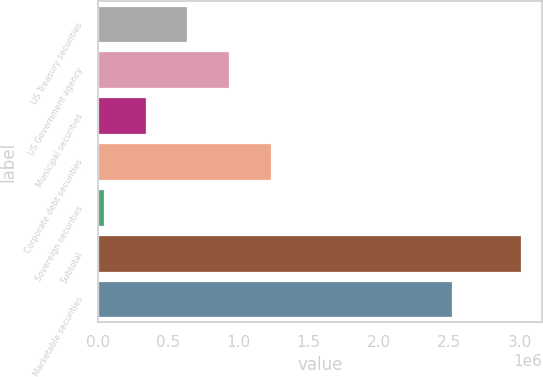<chart> <loc_0><loc_0><loc_500><loc_500><bar_chart><fcel>US Treasury securities<fcel>US Government agency<fcel>Municipal securities<fcel>Corporate debt securities<fcel>Sovereign securities<fcel>Subtotal<fcel>Marketable securities<nl><fcel>636293<fcel>933307<fcel>339278<fcel>1.23032e+06<fcel>42264<fcel>3.01241e+06<fcel>2.52178e+06<nl></chart> 